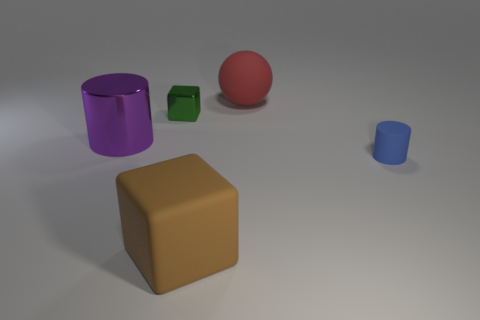There is a purple metal thing on the left side of the shiny block; does it have the same shape as the big rubber thing in front of the small blue rubber object?
Offer a very short reply. No. Is the number of brown matte things that are in front of the big block the same as the number of red rubber spheres?
Your answer should be very brief. No. What is the color of the big shiny object that is the same shape as the small rubber thing?
Offer a terse response. Purple. Is the thing behind the green cube made of the same material as the big brown thing?
Your response must be concise. Yes. How many small things are blue cylinders or red cubes?
Provide a succinct answer. 1. What size is the red matte thing?
Provide a short and direct response. Large. There is a green thing; does it have the same size as the cylinder that is behind the blue thing?
Offer a very short reply. No. What number of blue objects are small objects or shiny things?
Provide a succinct answer. 1. What number of tiny rubber things are there?
Provide a succinct answer. 1. There is a cylinder right of the tiny shiny block; what size is it?
Your answer should be very brief. Small. 